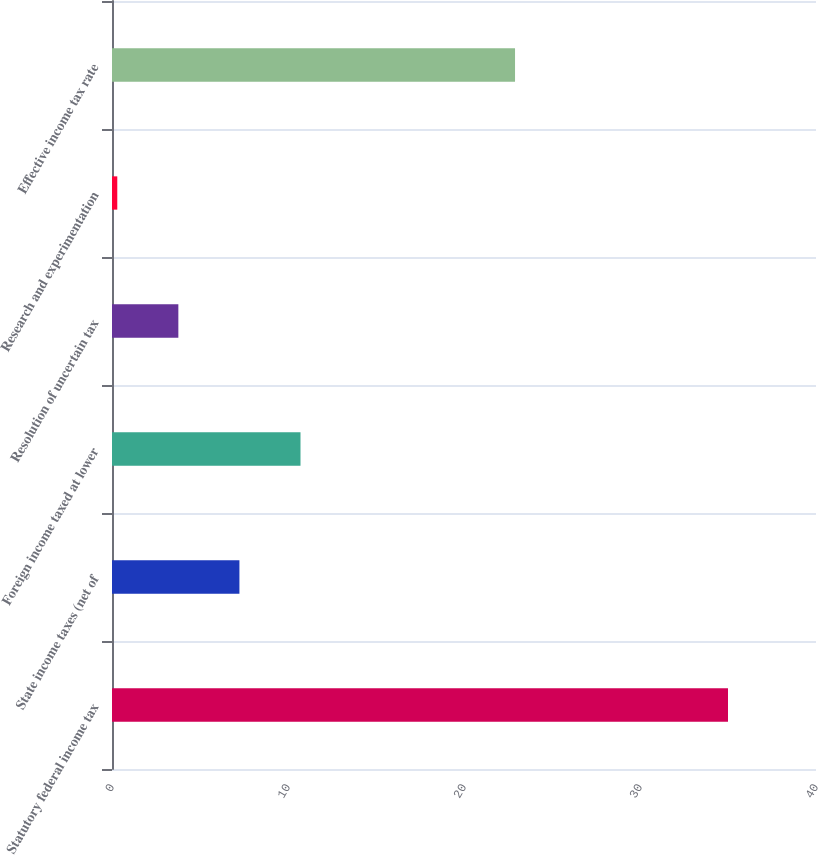Convert chart to OTSL. <chart><loc_0><loc_0><loc_500><loc_500><bar_chart><fcel>Statutory federal income tax<fcel>State income taxes (net of<fcel>Foreign income taxed at lower<fcel>Resolution of uncertain tax<fcel>Research and experimentation<fcel>Effective income tax rate<nl><fcel>35<fcel>7.24<fcel>10.71<fcel>3.77<fcel>0.3<fcel>22.9<nl></chart> 